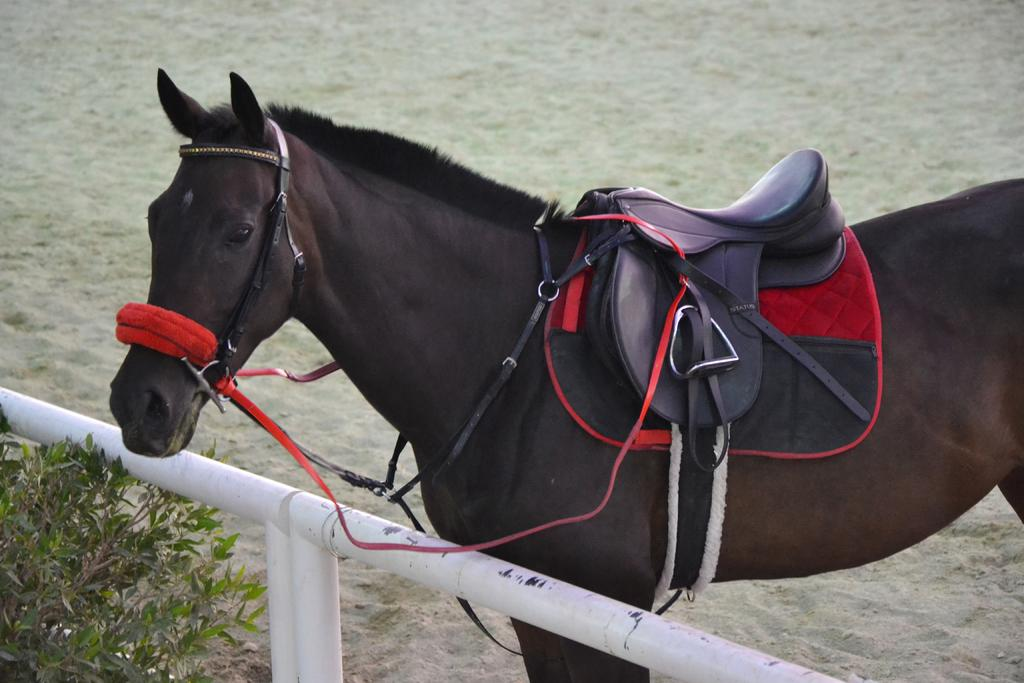What type of animal is in the image? There is a brown color horse in the image. Where is the horse located in relation to the railing? The horse is behind a railing. What color is the railing? The railing is in white color. What can be seen on the left side of the image? There is a plant on the left side of the image. How many cherries are on the horse's back in the image? There are no cherries present in the image, and the horse's back is not mentioned in the facts provided. 